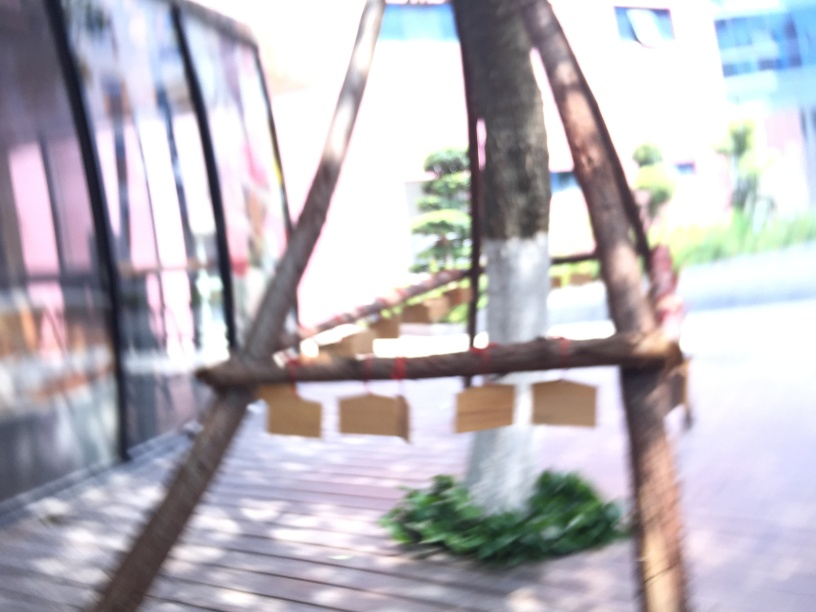What visual elements suggest that this is an outdoor setting? The presence of bright light suggesting sunlight, vegetation around the structure, and distant buildings partially visible despite the overexposure are all indicators that this is an outdoor setting. 